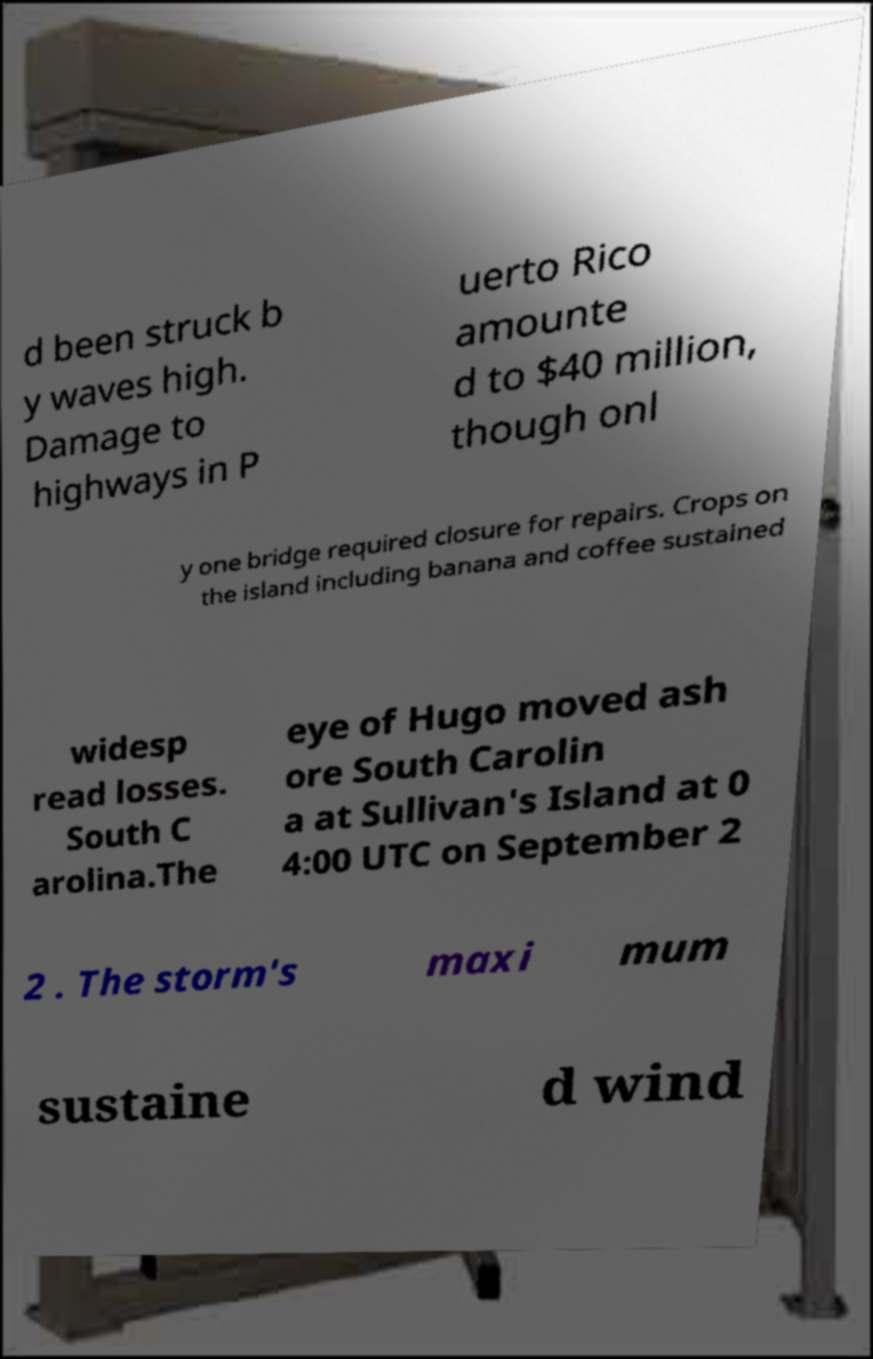Could you extract and type out the text from this image? d been struck b y waves high. Damage to highways in P uerto Rico amounte d to $40 million, though onl y one bridge required closure for repairs. Crops on the island including banana and coffee sustained widesp read losses. South C arolina.The eye of Hugo moved ash ore South Carolin a at Sullivan's Island at 0 4:00 UTC on September 2 2 . The storm's maxi mum sustaine d wind 